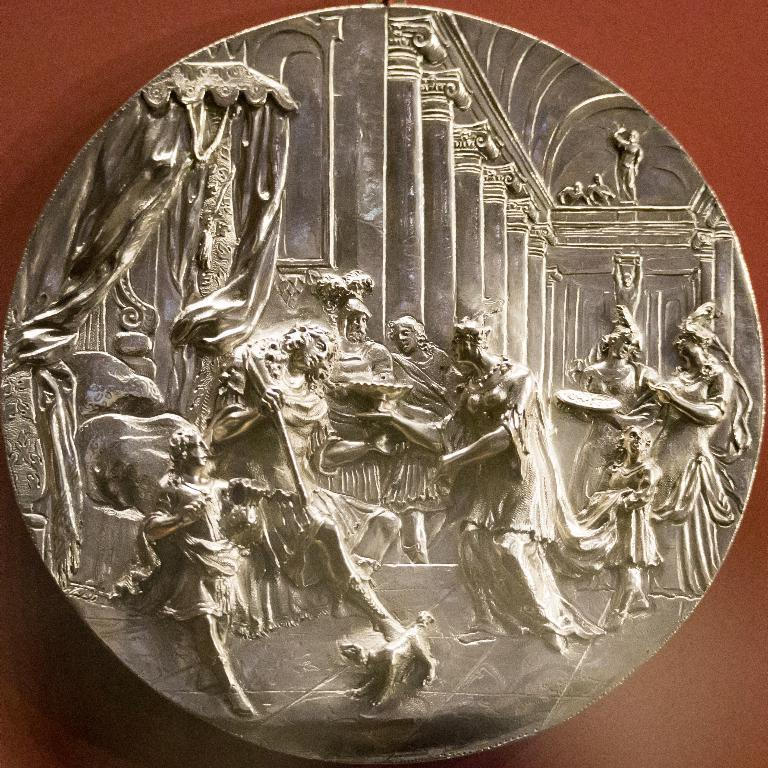What is the main subject of the image? The main subject of the image is a coin. What can be seen on the coin? There are sculptures on the coin. What is the color of the background in the image? The background of the image appears to be brown in color. What type of wound can be seen on the coin in the image? There is no wound present on the coin in the image. What type of badge is depicted on the coin in the image? There is no badge depicted on the coin in the image. 